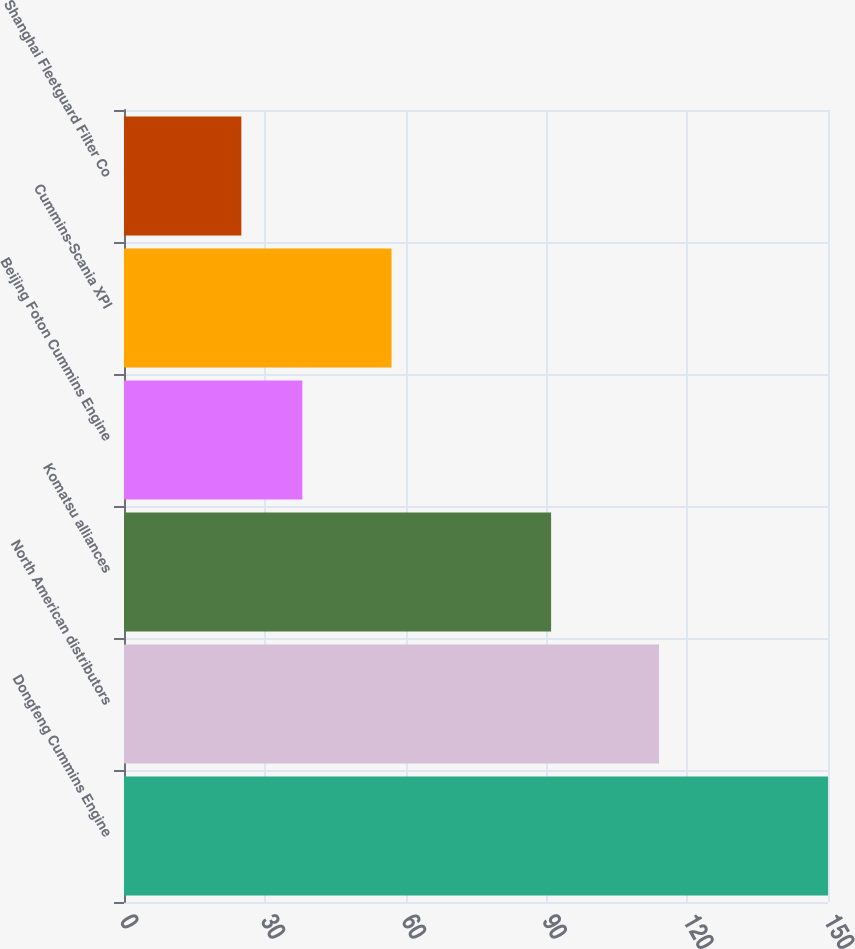<chart> <loc_0><loc_0><loc_500><loc_500><bar_chart><fcel>Dongfeng Cummins Engine<fcel>North American distributors<fcel>Komatsu alliances<fcel>Beijing Foton Cummins Engine<fcel>Cummins-Scania XPI<fcel>Shanghai Fleetguard Filter Co<nl><fcel>150<fcel>114<fcel>91<fcel>38<fcel>57<fcel>25<nl></chart> 